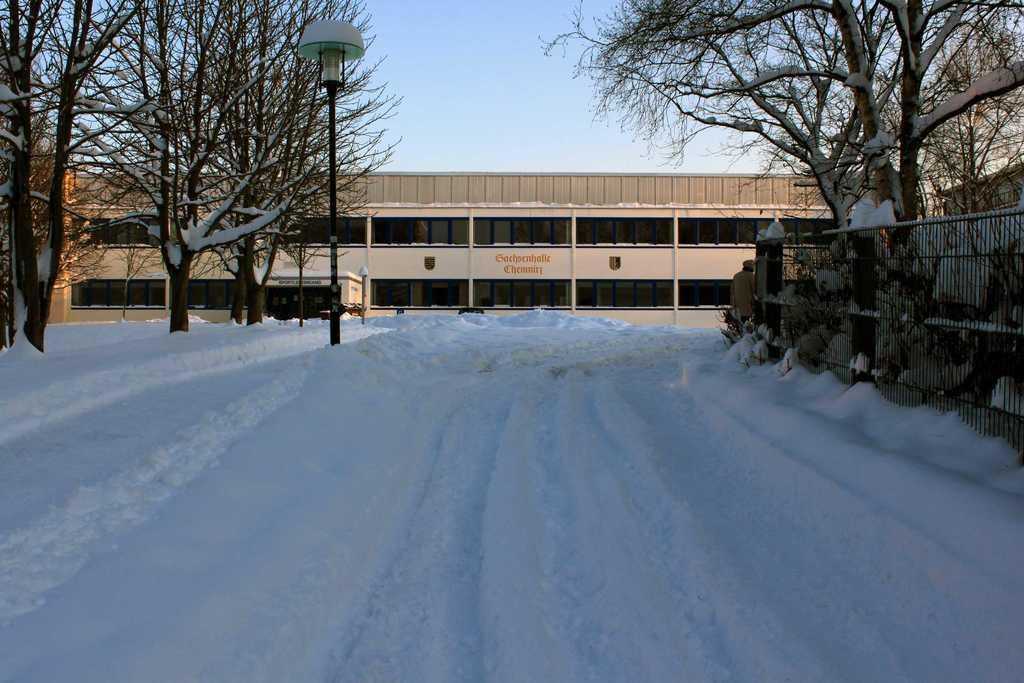What type of weather condition is depicted in the image? There is snow in the image, indicating a cold or wintry weather condition. What can be seen near the snow in the image? There is a railing, trees, and a black-colored pole in the image. What type of structure is visible in the image? There is a building in the image, which is cream in color. What is visible in the background of the image? The sky is visible in the background of the image. How many beds can be seen in the image? There are no beds present in the image. What type of arm is visible in the image? There is no arm visible in the image. 